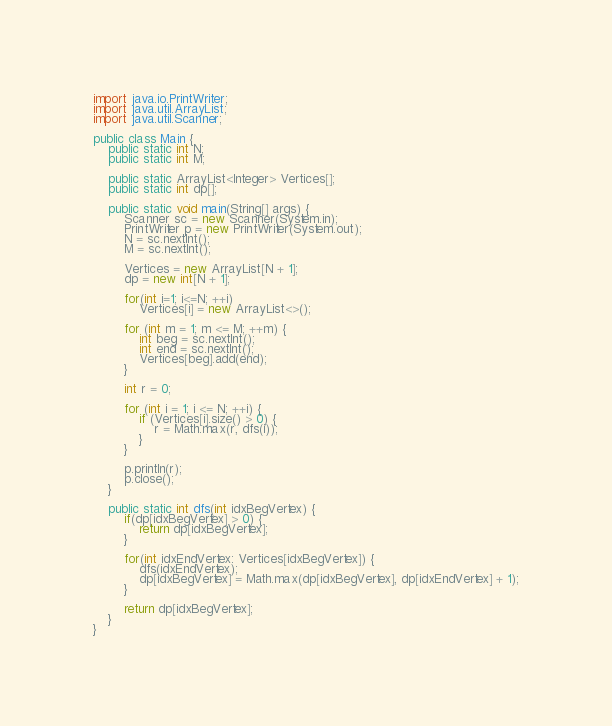<code> <loc_0><loc_0><loc_500><loc_500><_Java_>import java.io.PrintWriter;
import java.util.ArrayList;
import java.util.Scanner;

public class Main {
    public static int N;
    public static int M;

    public static ArrayList<Integer> Vertices[];
    public static int dp[];

    public static void main(String[] args) {
        Scanner sc = new Scanner(System.in);
        PrintWriter p = new PrintWriter(System.out);
        N = sc.nextInt();
        M = sc.nextInt();

        Vertices = new ArrayList[N + 1];
        dp = new int[N + 1];

        for(int i=1; i<=N; ++i)
            Vertices[i] = new ArrayList<>();

        for (int m = 1; m <= M; ++m) {
            int beg = sc.nextInt();
            int end = sc.nextInt();
            Vertices[beg].add(end);
        }

        int r = 0;

        for (int i = 1; i <= N; ++i) {
            if (Vertices[i].size() > 0) {
                r = Math.max(r, dfs(i));
            }
        }

        p.println(r);
        p.close();
    }

    public static int dfs(int idxBegVertex) {
        if(dp[idxBegVertex] > 0) {
            return dp[idxBegVertex];
        }

        for(int idxEndVertex: Vertices[idxBegVertex]) {
            dfs(idxEndVertex);
            dp[idxBegVertex] = Math.max(dp[idxBegVertex], dp[idxEndVertex] + 1);
        }

        return dp[idxBegVertex];
    }
}
</code> 